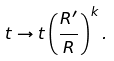Convert formula to latex. <formula><loc_0><loc_0><loc_500><loc_500>t \rightarrow t \left ( \frac { R ^ { \prime } } { R } \right ) ^ { k } .</formula> 